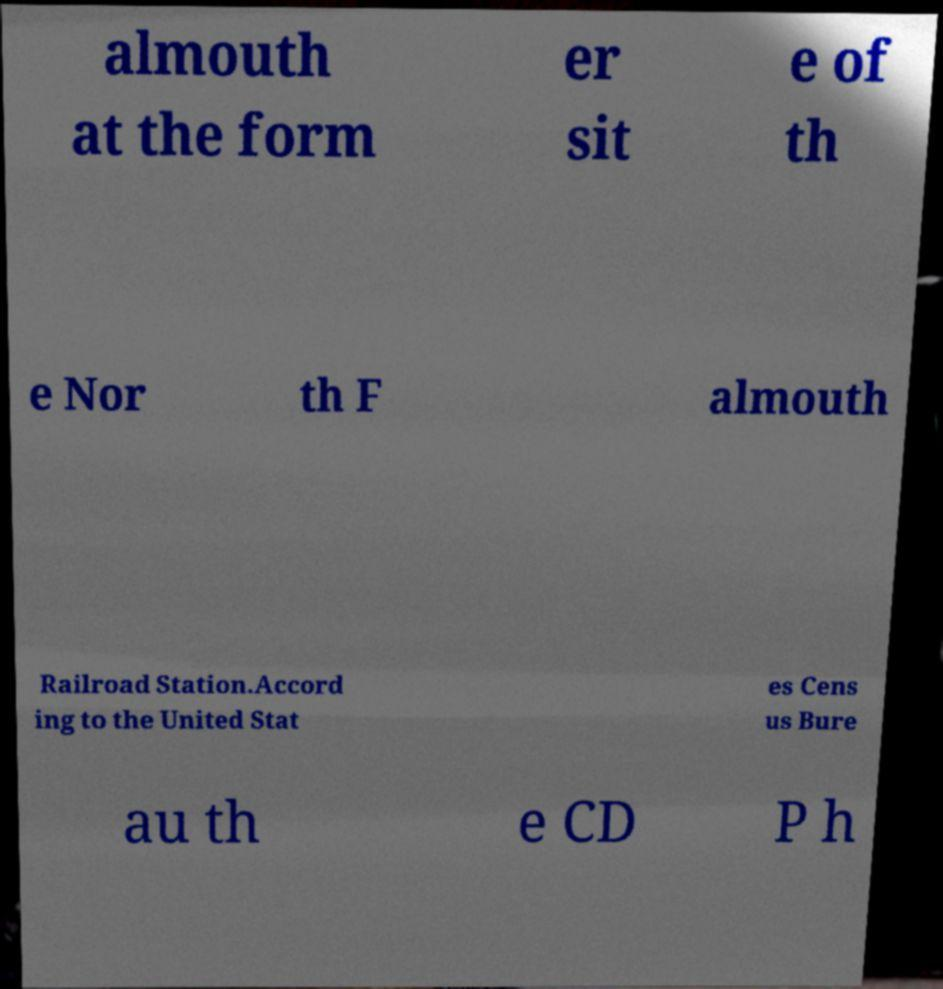Please identify and transcribe the text found in this image. almouth at the form er sit e of th e Nor th F almouth Railroad Station.Accord ing to the United Stat es Cens us Bure au th e CD P h 